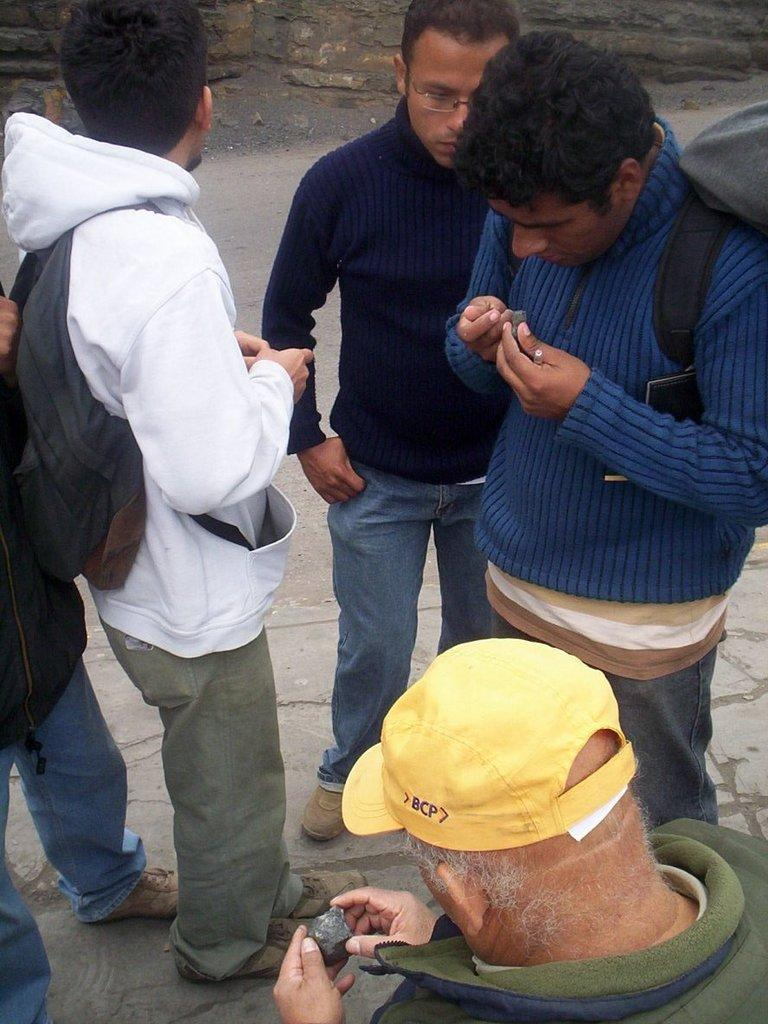How many people are in the group in the picture? There is a group of persons in the picture, but the exact number is not specified. What are two persons in the group doing with their hands? Two persons in the group are holding an object in their hands. What type of scarf is being worn by the person in space in the image? There is no person in space or wearing a scarf in the image. How many toes can be seen on the person standing on their toes in the image? There is no person standing on their toes in the image. 